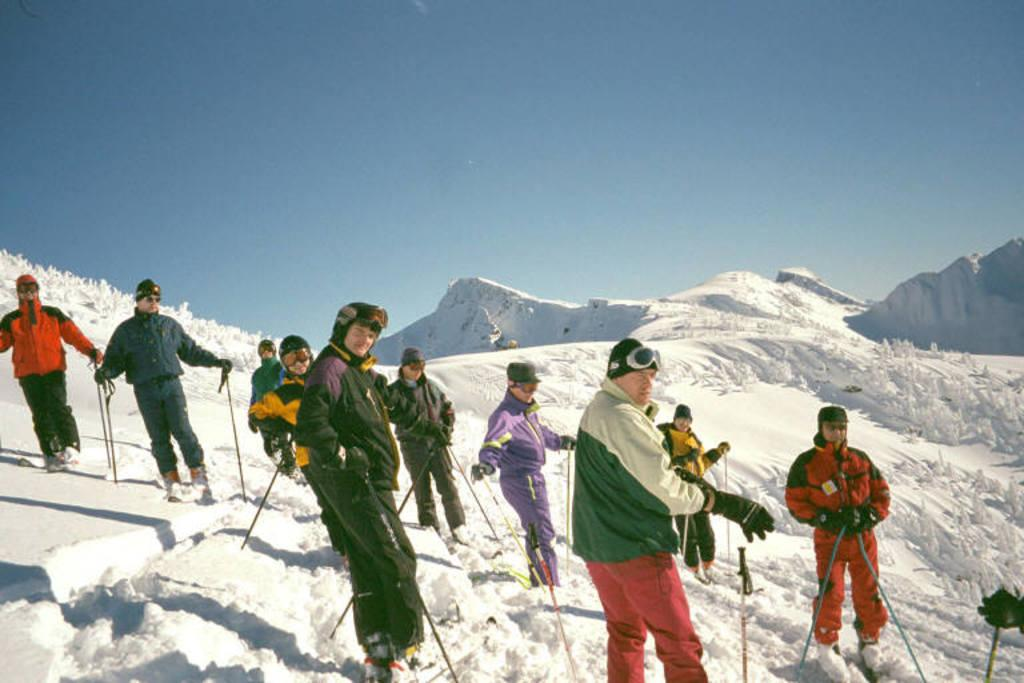How many people are in the image? There are people in the image, but the exact number is not specified. What are the people doing in the image? The people are standing in the image. What objects are the people holding in the image? The people are holding sticks, wire caps, and goggles in the image. What is the weather like in the image? There is snow visible in the image, indicating a cold or wintry environment. What is visible in the background of the image? There is sky visible in the background of the image. What type of skirt is the person wearing in the image? There is no mention of a skirt in the image, as the people are holding sticks, wire caps, and goggles. What story is being told by the people in the image? There is no indication of a story being told in the image, as the people are simply standing and holding various objects. 